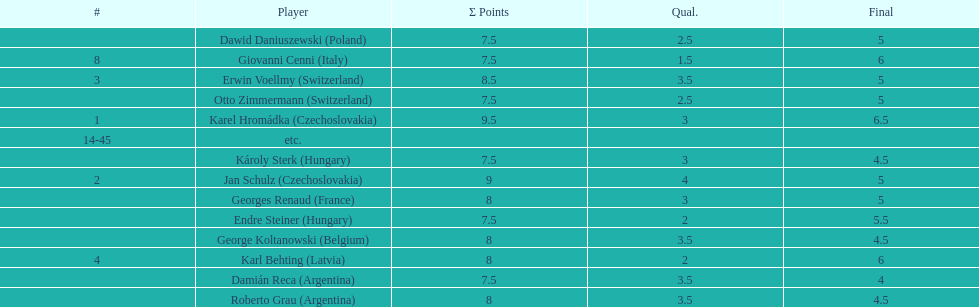Did the two competitors from hungary get more or less combined points than the two competitors from argentina? Less. 